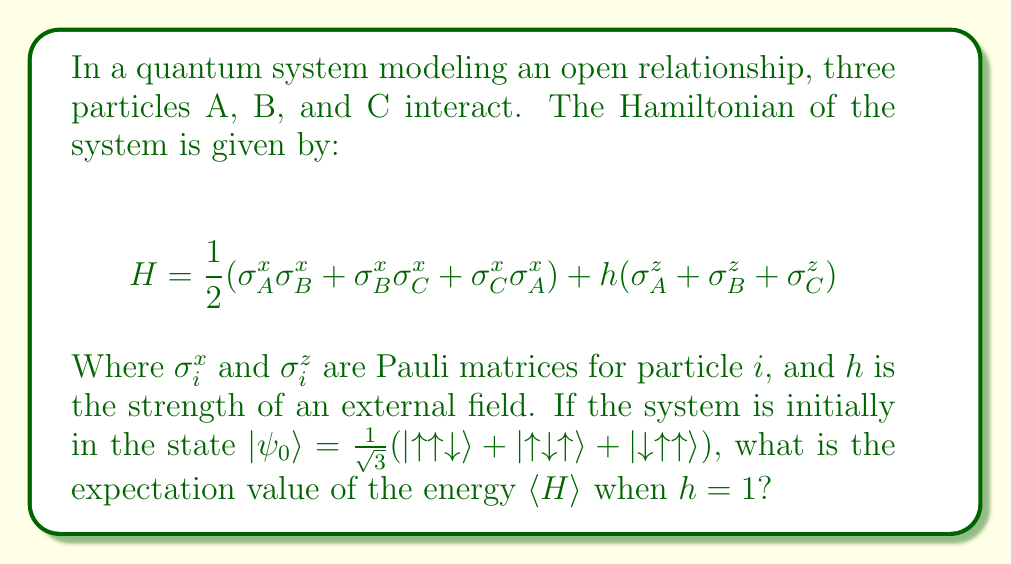What is the answer to this math problem? To solve this problem, we need to follow these steps:

1) First, let's evaluate the action of each term in the Hamiltonian on our initial state $|\psi_0\rangle$.

2) For the $\sigma_i^x \sigma_j^x$ terms:
   $\sigma_i^x |{\uparrow}\rangle = |{\downarrow}\rangle$ and $\sigma_i^x |{\downarrow}\rangle = |{\uparrow}\rangle$
   So, $\sigma_A^x \sigma_B^x |{\uparrow\uparrow\downarrow}\rangle = |{\downarrow\downarrow\downarrow}\rangle$
      $\sigma_B^x \sigma_C^x |{\uparrow\uparrow\downarrow}\rangle = |{\uparrow\downarrow\uparrow}\rangle$
      $\sigma_C^x \sigma_A^x |{\uparrow\uparrow\downarrow}\rangle = |{\downarrow\uparrow\downarrow}\rangle$

3) For the $\sigma_i^z$ terms:
   $\sigma_i^z |{\uparrow}\rangle = |{\uparrow}\rangle$ and $\sigma_i^z |{\downarrow}\rangle = -|{\downarrow}\rangle$

4) Now, let's calculate $\langle\psi_0|H|\psi_0\rangle$:

   $\langle\psi_0|H|\psi_0\rangle = \frac{1}{2}(\langle\psi_0|\sigma_A^x \sigma_B^x|\psi_0\rangle + \langle\psi_0|\sigma_B^x \sigma_C^x|\psi_0\rangle + \langle\psi_0|\sigma_C^x \sigma_A^x|\psi_0\rangle) + h(\langle\psi_0|\sigma_A^z|\psi_0\rangle + \langle\psi_0|\sigma_B^z|\psi_0\rangle + \langle\psi_0|\sigma_C^z|\psi_0\rangle)$

5) For the $\sigma_i^x \sigma_j^x$ terms:
   $\langle\psi_0|\sigma_A^x \sigma_B^x|\psi_0\rangle = \langle\psi_0|\sigma_B^x \sigma_C^x|\psi_0\rangle = \langle\psi_0|\sigma_C^x \sigma_A^x|\psi_0\rangle = \frac{1}{3}$

6) For the $\sigma_i^z$ terms:
   $\langle\psi_0|\sigma_A^z|\psi_0\rangle = \langle\psi_0|\sigma_B^z|\psi_0\rangle = \langle\psi_0|\sigma_C^z|\psi_0\rangle = \frac{1}{3}$

7) Substituting these values:

   $\langle\psi_0|H|\psi_0\rangle = \frac{1}{2}(\frac{1}{3} + \frac{1}{3} + \frac{1}{3}) + h(\frac{1}{3} + \frac{1}{3} + \frac{1}{3})$

8) Simplifying:

   $\langle\psi_0|H|\psi_0\rangle = \frac{1}{2} + h$

9) Given $h = 1$, we have:

   $\langle\psi_0|H|\psi_0\rangle = \frac{1}{2} + 1 = \frac{3}{2}$

Therefore, the expectation value of the energy is $\frac{3}{2}$.
Answer: $\frac{3}{2}$ 